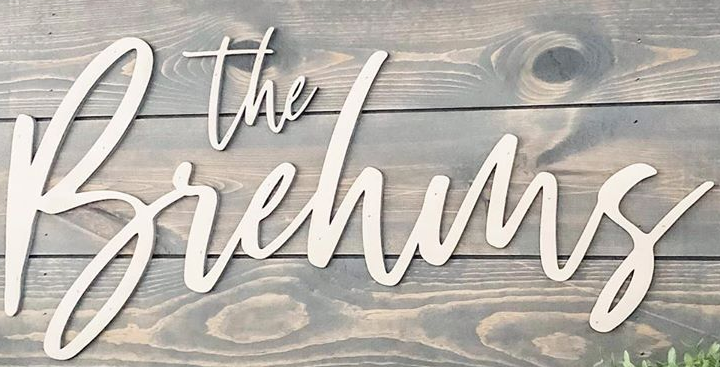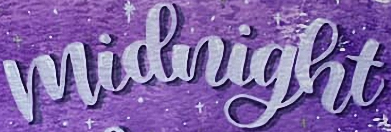Read the text content from these images in order, separated by a semicolon. Brehms; midnight 